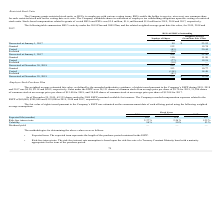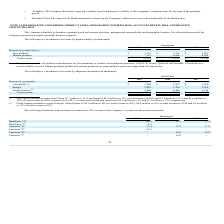From Quicklogic Corporation's financial document, What are the respective weighted average estimated fair value of the company's ESPP during 2019 and 2018? The document shows two values: $4.28 and $5.18. From the document: "and 2017 was $4.28, $5.18 and $6.02, respectively. Sales under the ESPP were 24,131 shares of common stock at an avera and 2017 was $4.28, $5.18 and $..." Also, What are the respective weighted average estimated fair value of the company's ESPP during 2018 and 2017? The document shows two values: $5.18 and $6.02. From the document: "and 2017 was $4.28, $5.18 and $6.02, respectively. Sales under the ESPP were 24,131 shares of common stock at an average price per shar and 2017 was $..." Also, What are the respective compensation expenses related to the ESPP in 2019 and 2018 respectively? The document shows two values: $60,000 and $205,000. From the document: "ESPP of $60,000, $205,000 and $153,000 in 2019, 2018 and 2017, respectively. ESPP of $60,000, $205,000 and $153,000 in 2019, 2018 and 2017, respective..." Also, can you calculate: What is the average risk-free interest rate of the company's ESPP in 2017 and 2018? To answer this question, I need to perform calculations using the financial data. The calculation is: (1.22 + 2.26)/2 , which equals 1.74 (percentage). This is based on the information: "Risk-free interest rate 2.37 % 2.26 % 1.22 % Risk-free interest rate 2.37 % 2.26 % 1.22 %..." The key data points involved are: 1.22, 2.26. Also, can you calculate: What is the average risk-free interest rate of the company's ESPP in 2018 and 2019? To answer this question, I need to perform calculations using the financial data. The calculation is: (2.26 + 2.37)/2 , which equals 2.32 (percentage). This is based on the information: "Risk-free interest rate 2.37 % 2.26 % 1.22 % Risk-free interest rate 2.37 % 2.26 % 1.22 %..." The key data points involved are: 2.26, 2.37. Also, can you calculate: What is the average volatility of the company's ESPP in 2018 and 2019? To answer this question, I need to perform calculations using the financial data. The calculation is: (54 + 50)/2 , which equals 52 (percentage). This is based on the information: "Volatility 54 % 50 % 53 % Volatility 54 % 50 % 53 %..." The key data points involved are: 50, 54. 